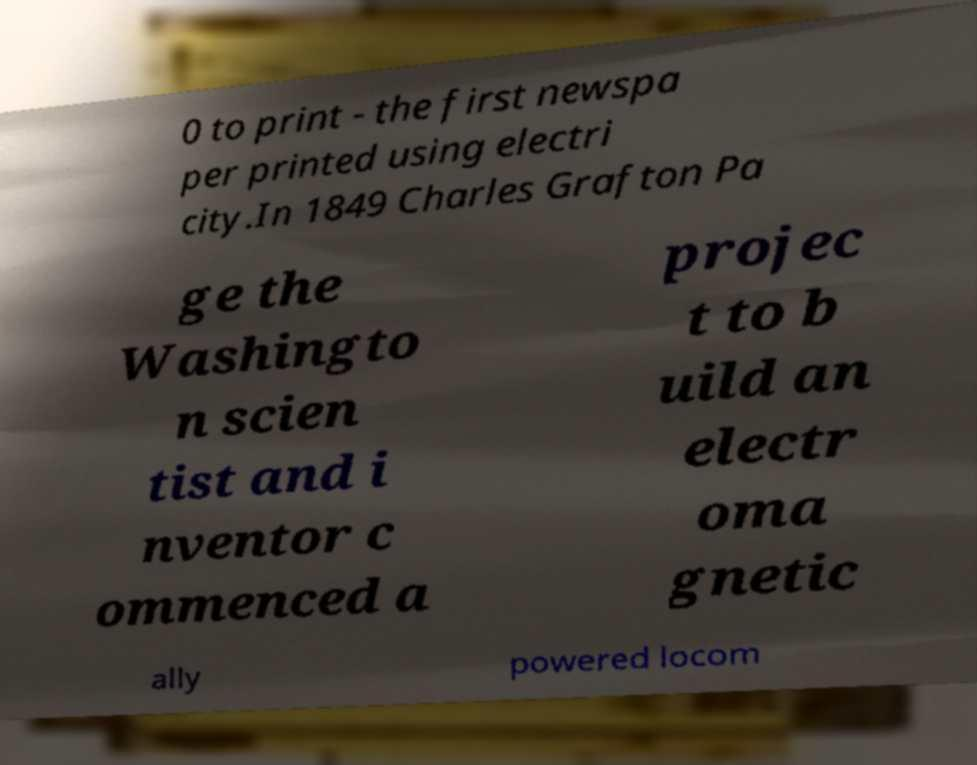For documentation purposes, I need the text within this image transcribed. Could you provide that? 0 to print - the first newspa per printed using electri city.In 1849 Charles Grafton Pa ge the Washingto n scien tist and i nventor c ommenced a projec t to b uild an electr oma gnetic ally powered locom 